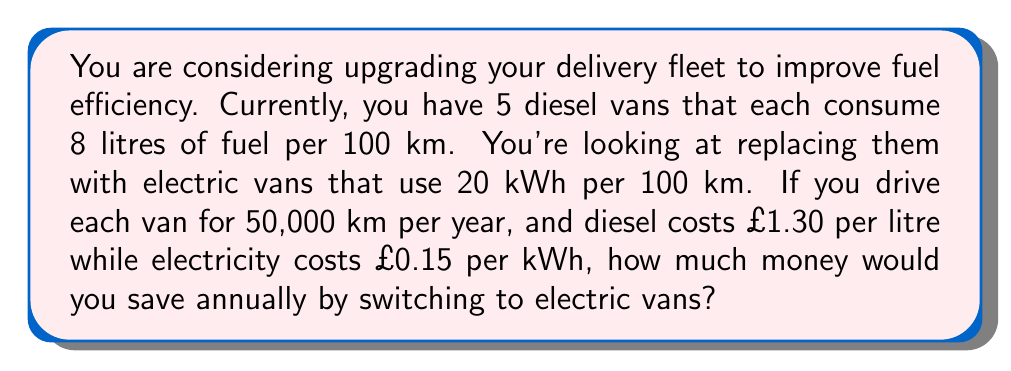Help me with this question. Let's break this down step-by-step:

1) First, calculate the annual fuel consumption for diesel vans:
   - Each van uses 8 litres per 100 km
   - For 50,000 km, each van uses: $50,000 \times \frac{8}{100} = 4,000$ litres
   - For 5 vans: $5 \times 4,000 = 20,000$ litres per year

2) Calculate the annual cost for diesel:
   $20,000 \times £1.30 = £26,000$

3) Now, calculate the annual electricity consumption for electric vans:
   - Each van uses 20 kWh per 100 km
   - For 50,000 km, each van uses: $50,000 \times \frac{20}{100} = 10,000$ kWh
   - For 5 vans: $5 \times 10,000 = 50,000$ kWh per year

4) Calculate the annual cost for electricity:
   $50,000 \times £0.15 = £7,500$

5) Calculate the difference in annual costs:
   $£26,000 - £7,500 = £18,500$

Therefore, by switching to electric vans, you would save £18,500 annually.
Answer: £18,500 